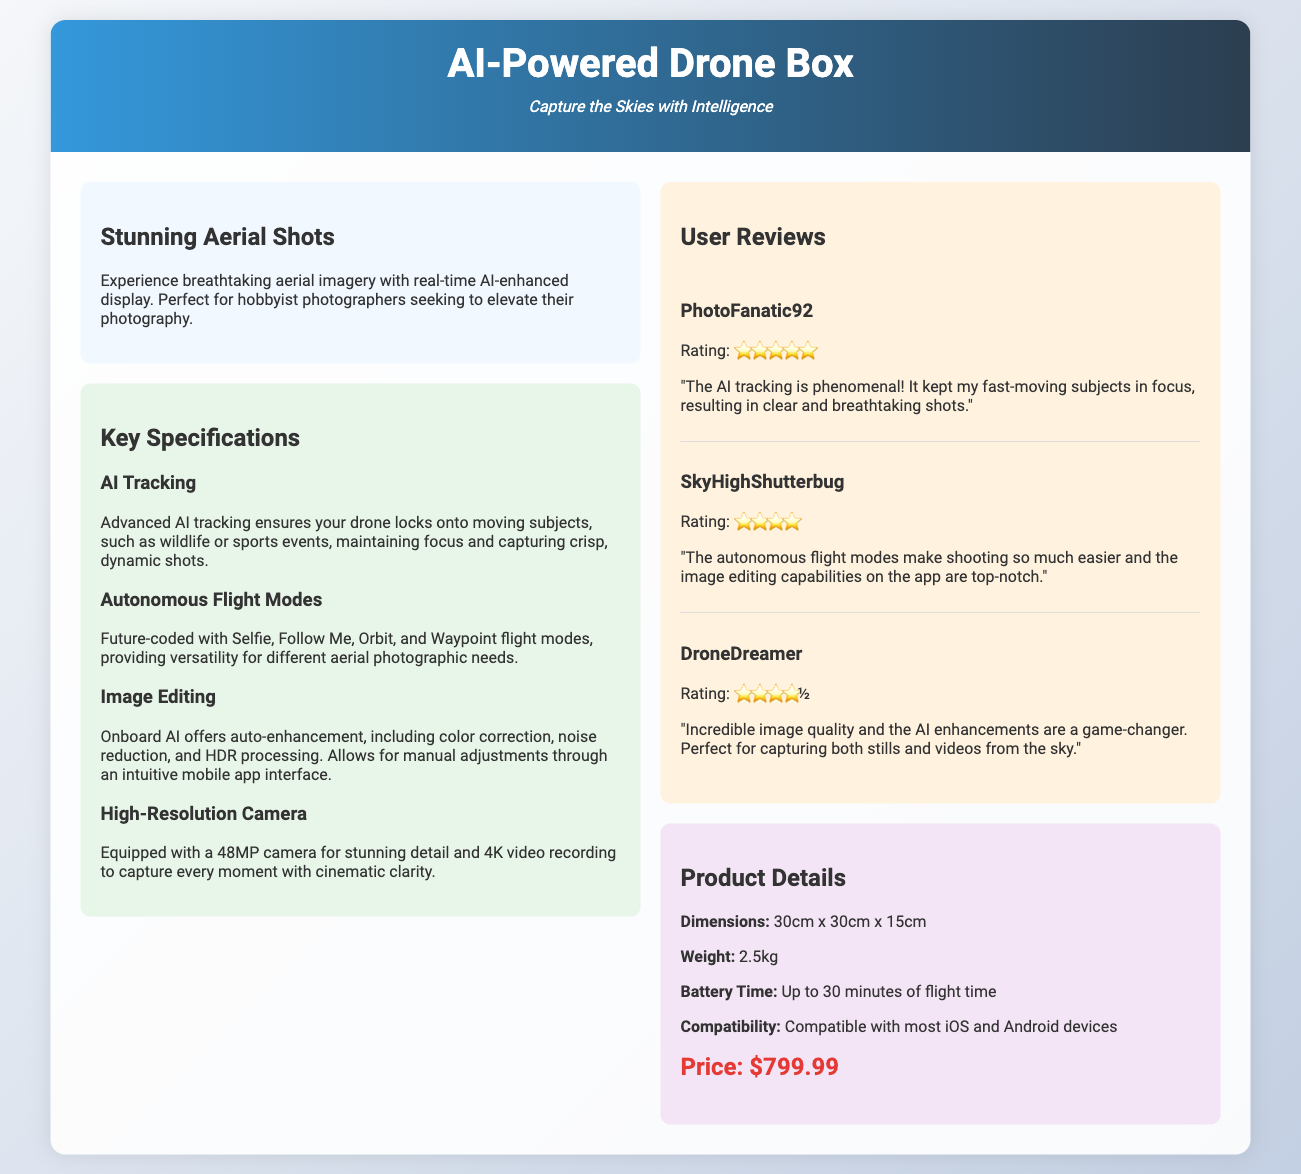What is the camera resolution of the drone? The document states the drone is equipped with a 48MP camera.
Answer: 48MP How many autonomous flight modes are mentioned? The drone features four autonomous flight modes according to the specifications.
Answer: Four What user rated the drone five stars? The review mentions a user named PhotoFanatic92 who gave a five-star rating.
Answer: PhotoFanatic92 What is the maximum battery time for flight? The specifications indicate that the drone has up to 30 minutes of battery time.
Answer: 30 minutes What is the price of the AI-Powered Drone Box? The document lists the price of the drone as $799.99.
Answer: $799.99 Which flight mode is specifically highlighted for selfies? The document mentions a Selfie flight mode among the autonomous features.
Answer: Selfie What editing features does the onboard AI offer? The specifications highlight color correction, noise reduction, and HDR processing as editing features.
Answer: Auto-enhancement Which user provided a review mentioning “top-notch” editing capabilities? SkyHighShutterbug is the user who mentioned the editing capabilities in their review.
Answer: SkyHighShutterbug What type of imagery is emphasized in the drone's marketing? The document emphasizes breathtaking aerial imagery.
Answer: Aerial imagery 